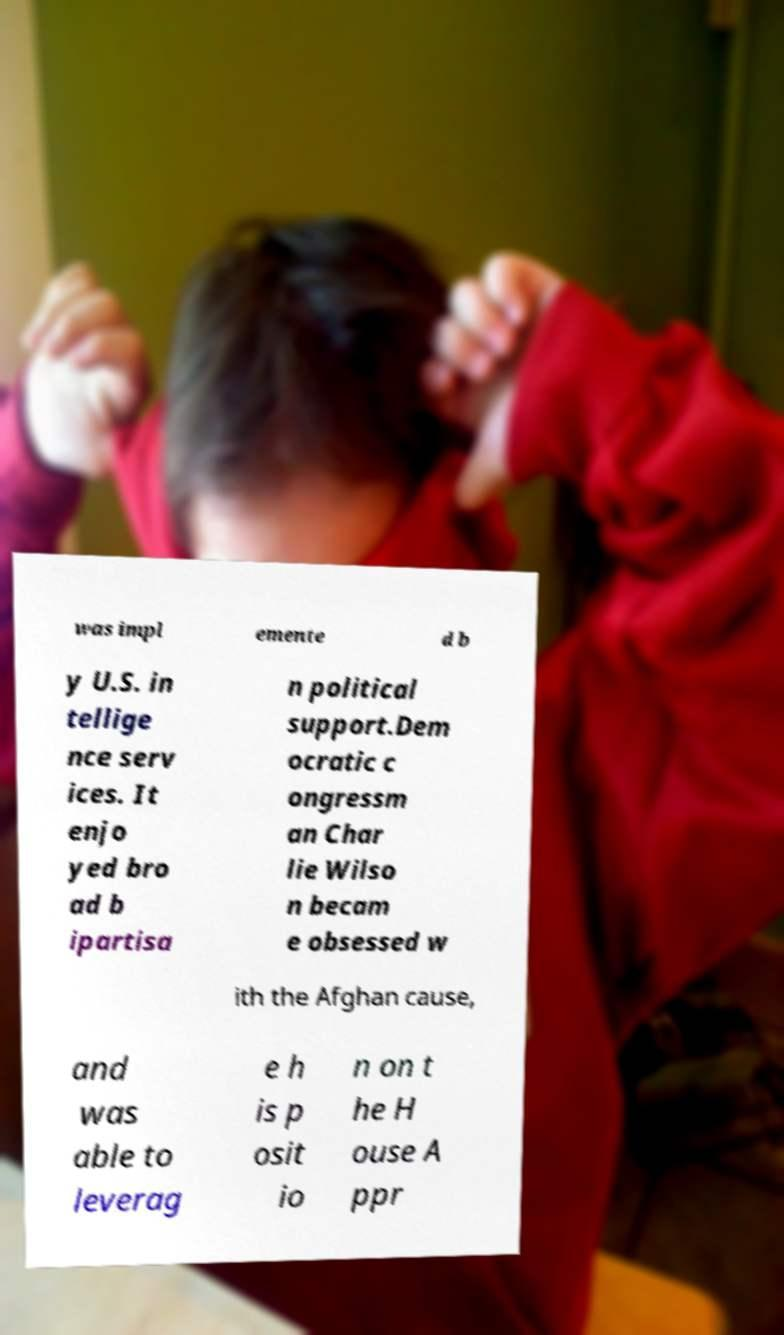Please identify and transcribe the text found in this image. was impl emente d b y U.S. in tellige nce serv ices. It enjo yed bro ad b ipartisa n political support.Dem ocratic c ongressm an Char lie Wilso n becam e obsessed w ith the Afghan cause, and was able to leverag e h is p osit io n on t he H ouse A ppr 